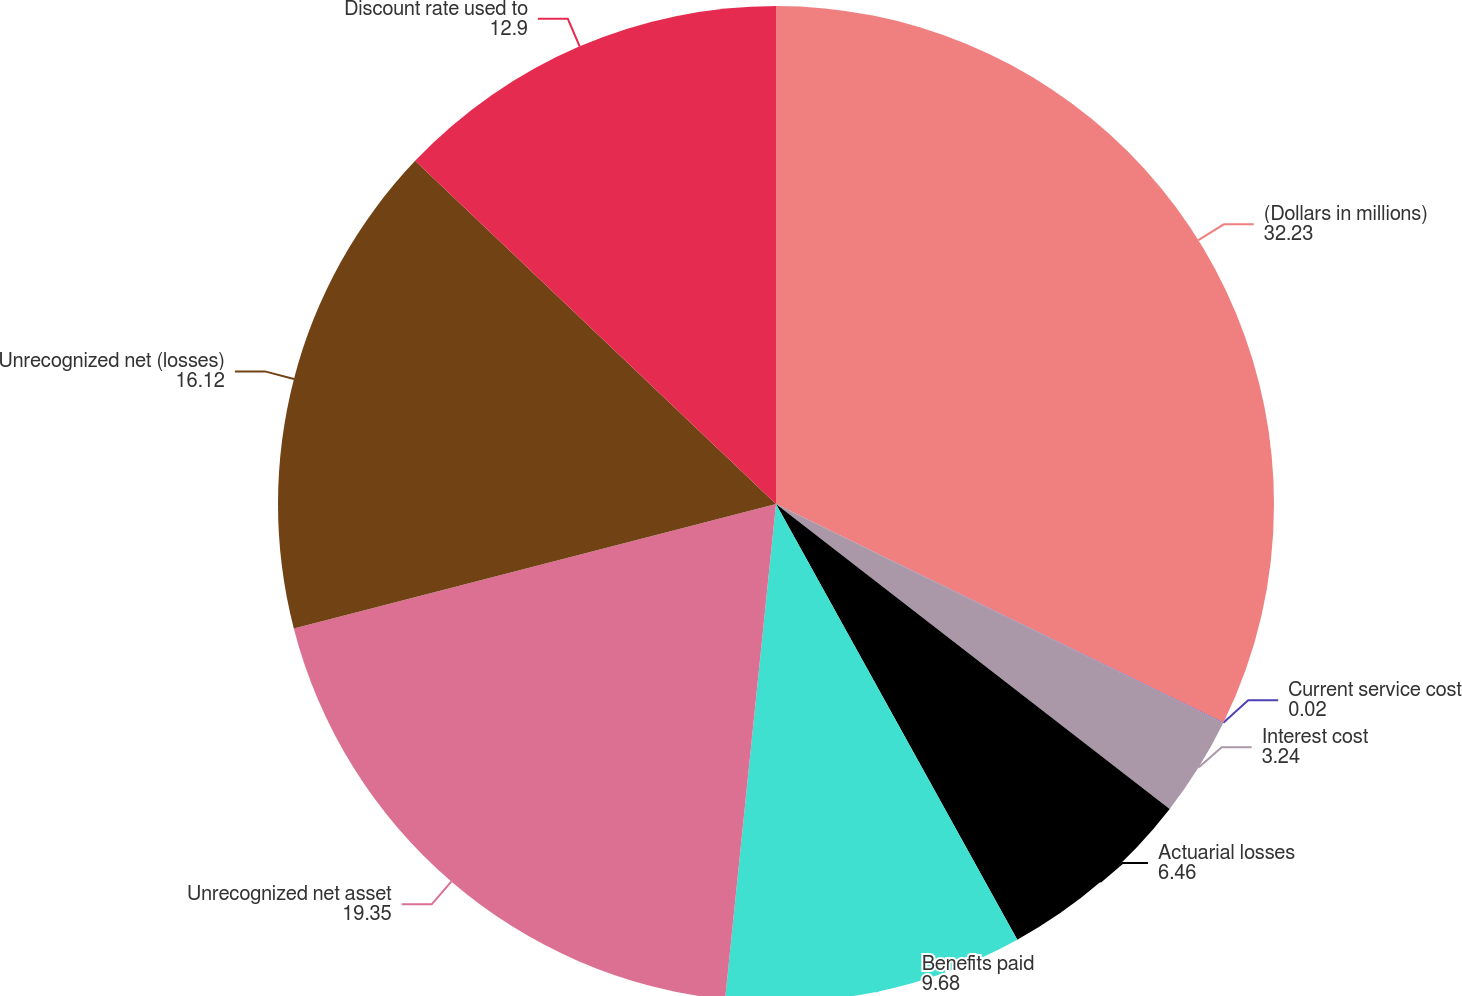Convert chart to OTSL. <chart><loc_0><loc_0><loc_500><loc_500><pie_chart><fcel>(Dollars in millions)<fcel>Current service cost<fcel>Interest cost<fcel>Actuarial losses<fcel>Benefits paid<fcel>Unrecognized net asset<fcel>Unrecognized net (losses)<fcel>Discount rate used to<nl><fcel>32.23%<fcel>0.02%<fcel>3.24%<fcel>6.46%<fcel>9.68%<fcel>19.35%<fcel>16.12%<fcel>12.9%<nl></chart> 